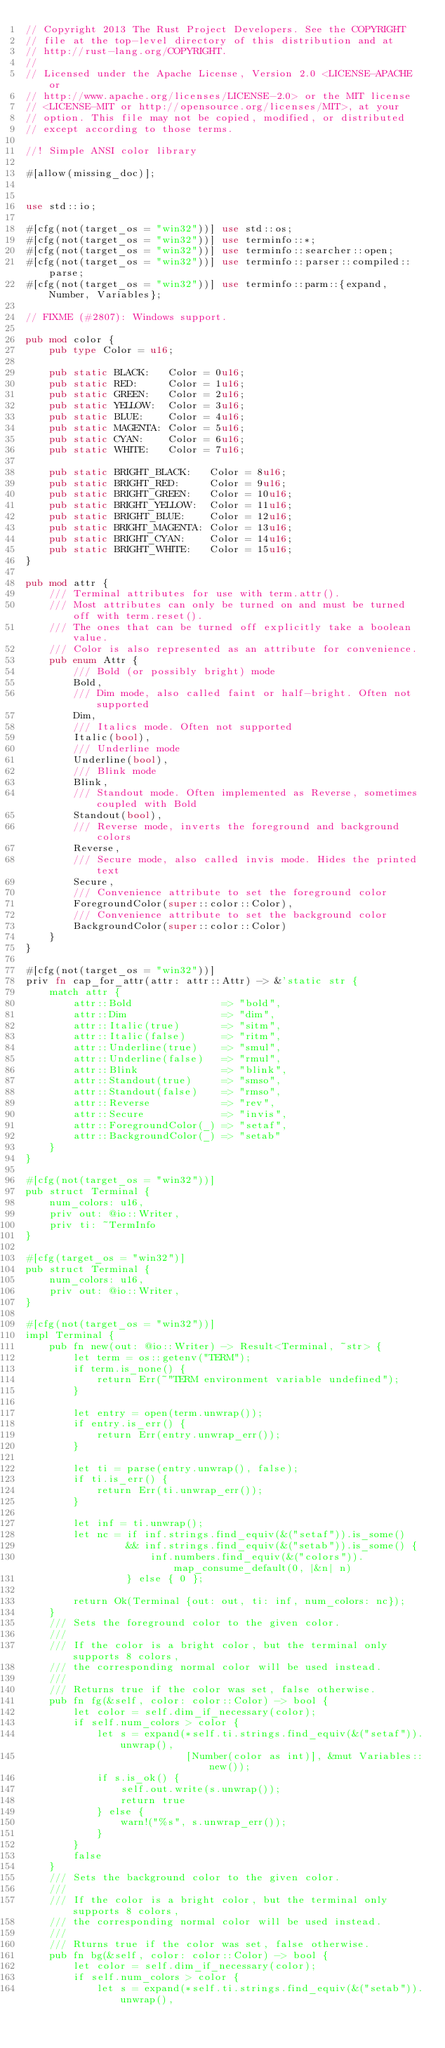Convert code to text. <code><loc_0><loc_0><loc_500><loc_500><_Rust_>// Copyright 2013 The Rust Project Developers. See the COPYRIGHT
// file at the top-level directory of this distribution and at
// http://rust-lang.org/COPYRIGHT.
//
// Licensed under the Apache License, Version 2.0 <LICENSE-APACHE or
// http://www.apache.org/licenses/LICENSE-2.0> or the MIT license
// <LICENSE-MIT or http://opensource.org/licenses/MIT>, at your
// option. This file may not be copied, modified, or distributed
// except according to those terms.

//! Simple ANSI color library

#[allow(missing_doc)];


use std::io;

#[cfg(not(target_os = "win32"))] use std::os;
#[cfg(not(target_os = "win32"))] use terminfo::*;
#[cfg(not(target_os = "win32"))] use terminfo::searcher::open;
#[cfg(not(target_os = "win32"))] use terminfo::parser::compiled::parse;
#[cfg(not(target_os = "win32"))] use terminfo::parm::{expand, Number, Variables};

// FIXME (#2807): Windows support.

pub mod color {
    pub type Color = u16;

    pub static BLACK:   Color = 0u16;
    pub static RED:     Color = 1u16;
    pub static GREEN:   Color = 2u16;
    pub static YELLOW:  Color = 3u16;
    pub static BLUE:    Color = 4u16;
    pub static MAGENTA: Color = 5u16;
    pub static CYAN:    Color = 6u16;
    pub static WHITE:   Color = 7u16;

    pub static BRIGHT_BLACK:   Color = 8u16;
    pub static BRIGHT_RED:     Color = 9u16;
    pub static BRIGHT_GREEN:   Color = 10u16;
    pub static BRIGHT_YELLOW:  Color = 11u16;
    pub static BRIGHT_BLUE:    Color = 12u16;
    pub static BRIGHT_MAGENTA: Color = 13u16;
    pub static BRIGHT_CYAN:    Color = 14u16;
    pub static BRIGHT_WHITE:   Color = 15u16;
}

pub mod attr {
    /// Terminal attributes for use with term.attr().
    /// Most attributes can only be turned on and must be turned off with term.reset().
    /// The ones that can be turned off explicitly take a boolean value.
    /// Color is also represented as an attribute for convenience.
    pub enum Attr {
        /// Bold (or possibly bright) mode
        Bold,
        /// Dim mode, also called faint or half-bright. Often not supported
        Dim,
        /// Italics mode. Often not supported
        Italic(bool),
        /// Underline mode
        Underline(bool),
        /// Blink mode
        Blink,
        /// Standout mode. Often implemented as Reverse, sometimes coupled with Bold
        Standout(bool),
        /// Reverse mode, inverts the foreground and background colors
        Reverse,
        /// Secure mode, also called invis mode. Hides the printed text
        Secure,
        /// Convenience attribute to set the foreground color
        ForegroundColor(super::color::Color),
        /// Convenience attribute to set the background color
        BackgroundColor(super::color::Color)
    }
}

#[cfg(not(target_os = "win32"))]
priv fn cap_for_attr(attr: attr::Attr) -> &'static str {
    match attr {
        attr::Bold               => "bold",
        attr::Dim                => "dim",
        attr::Italic(true)       => "sitm",
        attr::Italic(false)      => "ritm",
        attr::Underline(true)    => "smul",
        attr::Underline(false)   => "rmul",
        attr::Blink              => "blink",
        attr::Standout(true)     => "smso",
        attr::Standout(false)    => "rmso",
        attr::Reverse            => "rev",
        attr::Secure             => "invis",
        attr::ForegroundColor(_) => "setaf",
        attr::BackgroundColor(_) => "setab"
    }
}

#[cfg(not(target_os = "win32"))]
pub struct Terminal {
    num_colors: u16,
    priv out: @io::Writer,
    priv ti: ~TermInfo
}

#[cfg(target_os = "win32")]
pub struct Terminal {
    num_colors: u16,
    priv out: @io::Writer,
}

#[cfg(not(target_os = "win32"))]
impl Terminal {
    pub fn new(out: @io::Writer) -> Result<Terminal, ~str> {
        let term = os::getenv("TERM");
        if term.is_none() {
            return Err(~"TERM environment variable undefined");
        }

        let entry = open(term.unwrap());
        if entry.is_err() {
            return Err(entry.unwrap_err());
        }

        let ti = parse(entry.unwrap(), false);
        if ti.is_err() {
            return Err(ti.unwrap_err());
        }

        let inf = ti.unwrap();
        let nc = if inf.strings.find_equiv(&("setaf")).is_some()
                 && inf.strings.find_equiv(&("setab")).is_some() {
                     inf.numbers.find_equiv(&("colors")).map_consume_default(0, |&n| n)
                 } else { 0 };

        return Ok(Terminal {out: out, ti: inf, num_colors: nc});
    }
    /// Sets the foreground color to the given color.
    ///
    /// If the color is a bright color, but the terminal only supports 8 colors,
    /// the corresponding normal color will be used instead.
    ///
    /// Returns true if the color was set, false otherwise.
    pub fn fg(&self, color: color::Color) -> bool {
        let color = self.dim_if_necessary(color);
        if self.num_colors > color {
            let s = expand(*self.ti.strings.find_equiv(&("setaf")).unwrap(),
                           [Number(color as int)], &mut Variables::new());
            if s.is_ok() {
                self.out.write(s.unwrap());
                return true
            } else {
                warn!("%s", s.unwrap_err());
            }
        }
        false
    }
    /// Sets the background color to the given color.
    ///
    /// If the color is a bright color, but the terminal only supports 8 colors,
    /// the corresponding normal color will be used instead.
    ///
    /// Rturns true if the color was set, false otherwise.
    pub fn bg(&self, color: color::Color) -> bool {
        let color = self.dim_if_necessary(color);
        if self.num_colors > color {
            let s = expand(*self.ti.strings.find_equiv(&("setab")).unwrap(),</code> 